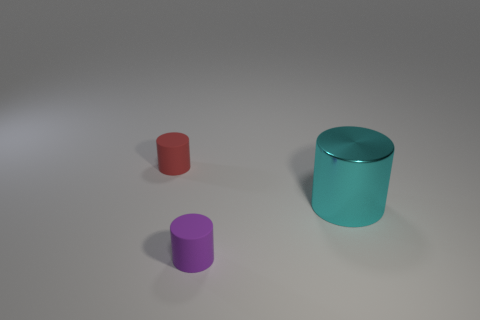How many cylinders are both in front of the tiny red cylinder and to the left of the cyan metal cylinder?
Provide a short and direct response. 1. Do the red matte thing and the purple matte cylinder have the same size?
Keep it short and to the point. Yes. There is a rubber thing that is right of the red thing; is it the same size as the big cyan metallic cylinder?
Your response must be concise. No. There is a small cylinder that is in front of the cyan object; what is its color?
Provide a succinct answer. Purple. What number of brown cubes are there?
Keep it short and to the point. 0. What is the shape of the small thing that is the same material as the small purple cylinder?
Provide a short and direct response. Cylinder. Is the color of the matte thing that is left of the small purple rubber cylinder the same as the tiny object in front of the red thing?
Keep it short and to the point. No. Are there the same number of large things to the right of the cyan metallic thing and cylinders?
Keep it short and to the point. No. How many big cyan objects are behind the purple thing?
Your answer should be very brief. 1. The cyan object is what size?
Your answer should be compact. Large. 